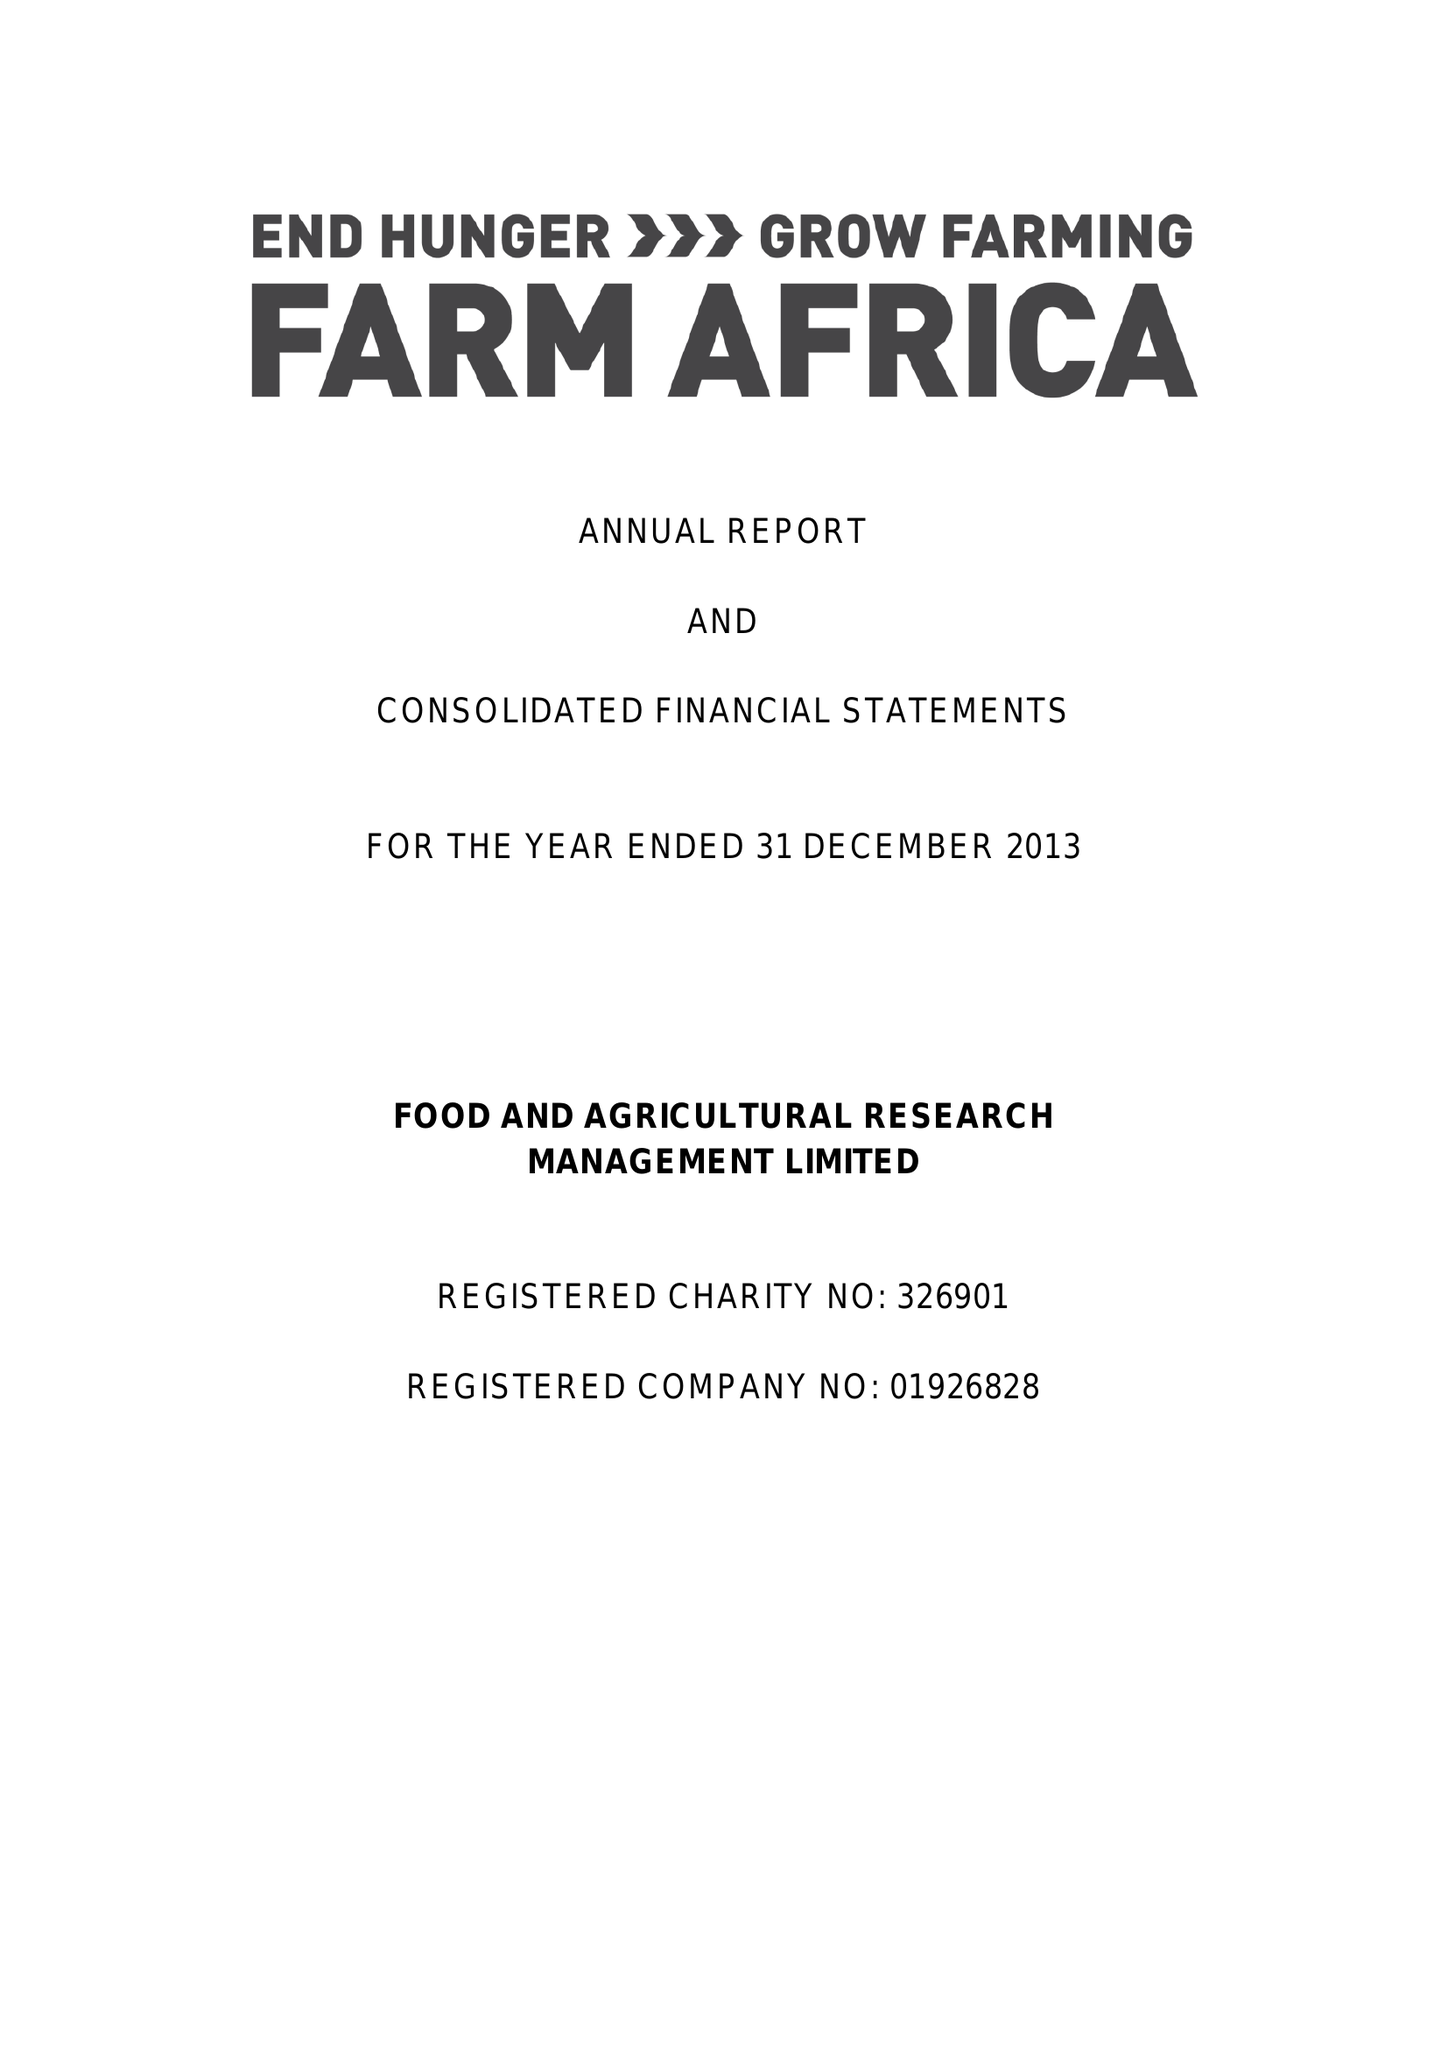What is the value for the address__postcode?
Answer the question using a single word or phrase. EC2Y 5DN 